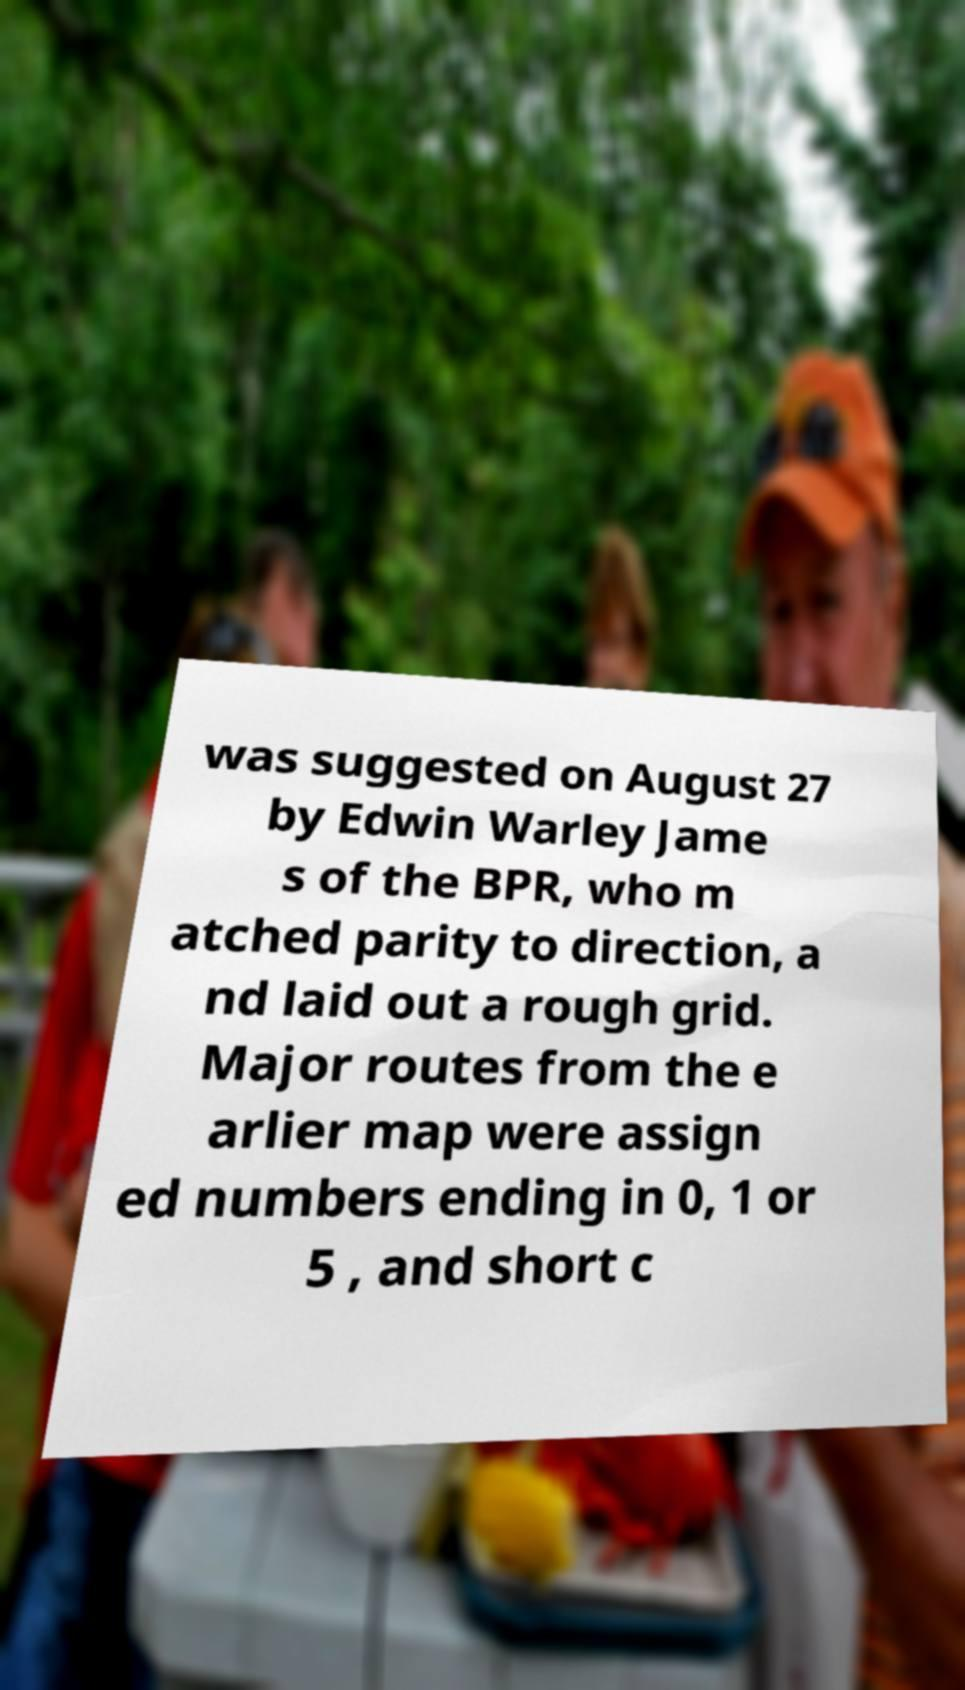Can you accurately transcribe the text from the provided image for me? was suggested on August 27 by Edwin Warley Jame s of the BPR, who m atched parity to direction, a nd laid out a rough grid. Major routes from the e arlier map were assign ed numbers ending in 0, 1 or 5 , and short c 